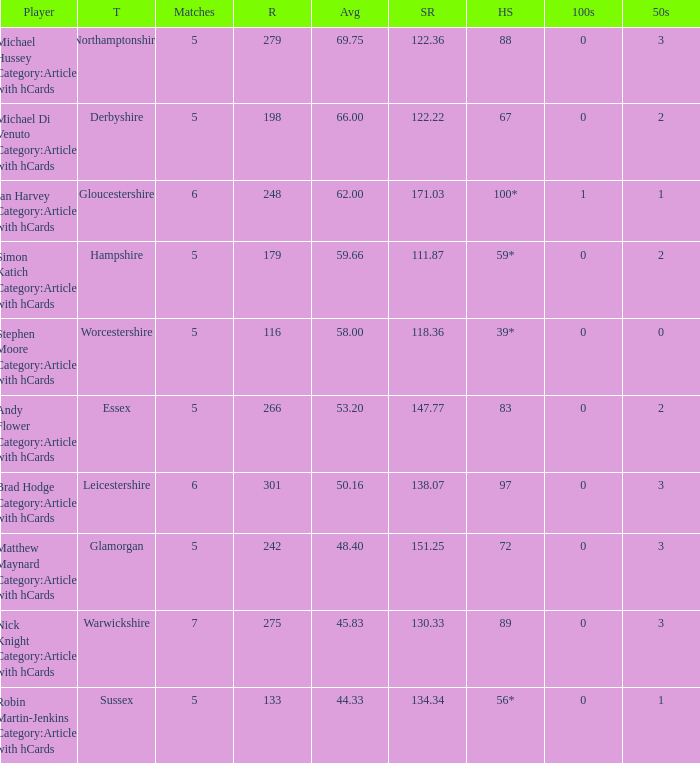If the team is Worcestershire and the Matched had were 5, what is the highest score? 39*. 